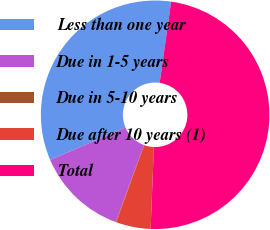Convert chart. <chart><loc_0><loc_0><loc_500><loc_500><pie_chart><fcel>Less than one year<fcel>Due in 1-5 years<fcel>Due in 5-10 years<fcel>Due after 10 years (1)<fcel>Total<nl><fcel>33.7%<fcel>12.92%<fcel>0.08%<fcel>4.91%<fcel>48.39%<nl></chart> 